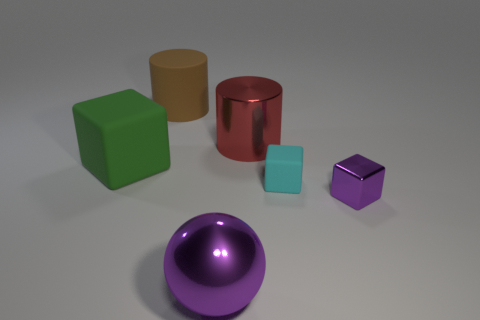Subtract all rubber cubes. How many cubes are left? 1 Subtract all red cylinders. How many cylinders are left? 1 Add 2 large cylinders. How many objects exist? 8 Subtract 0 green spheres. How many objects are left? 6 Subtract all balls. How many objects are left? 5 Subtract 1 balls. How many balls are left? 0 Subtract all cyan cubes. Subtract all cyan cylinders. How many cubes are left? 2 Subtract all small purple metal things. Subtract all purple spheres. How many objects are left? 4 Add 4 cyan rubber cubes. How many cyan rubber cubes are left? 5 Add 5 green rubber objects. How many green rubber objects exist? 6 